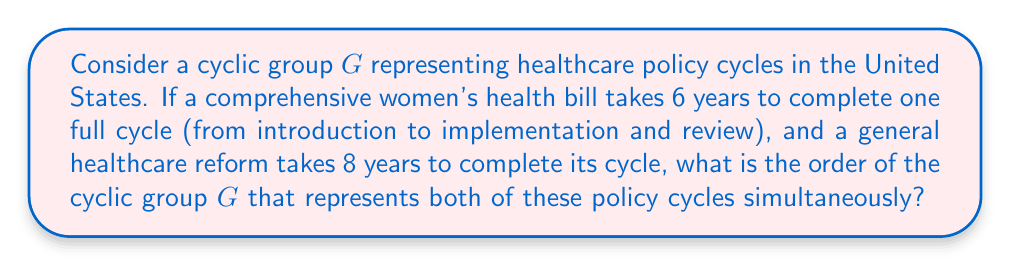Could you help me with this problem? To solve this problem, we need to consider the following steps:

1) In abstract algebra, a cyclic group is a group that can be generated by a single element. The order of a cyclic group is the smallest positive integer $n$ such that $g^n = e$, where $g$ is the generator and $e$ is the identity element.

2) In this case, we have two cycles:
   - Women's health bill cycle: 6 years
   - General healthcare reform cycle: 8 years

3) We need to find a cyclic group that can represent both of these cycles simultaneously. This means we need to find the least common multiple (LCM) of 6 and 8.

4) To find the LCM, we first factorize these numbers:
   $6 = 2 \times 3$
   $8 = 2^3$

5) The LCM will include the highest power of each prime factor:
   $LCM(6,8) = 2^3 \times 3 = 24$

6) This means that after 24 years, both cycles will complete simultaneously and the system will return to its initial state.

7) Therefore, the order of the cyclic group $G$ that represents both of these policy cycles is 24.

In terms of group theory, we can represent this as:
$$G = \langle g \rangle = \{g^k : k \in \mathbb{Z}\}$$
where $g^{24} = e$ (the identity element), and $g^k \neq e$ for $0 < k < 24$.
Answer: The order of the cyclic group $G$ is 24. 